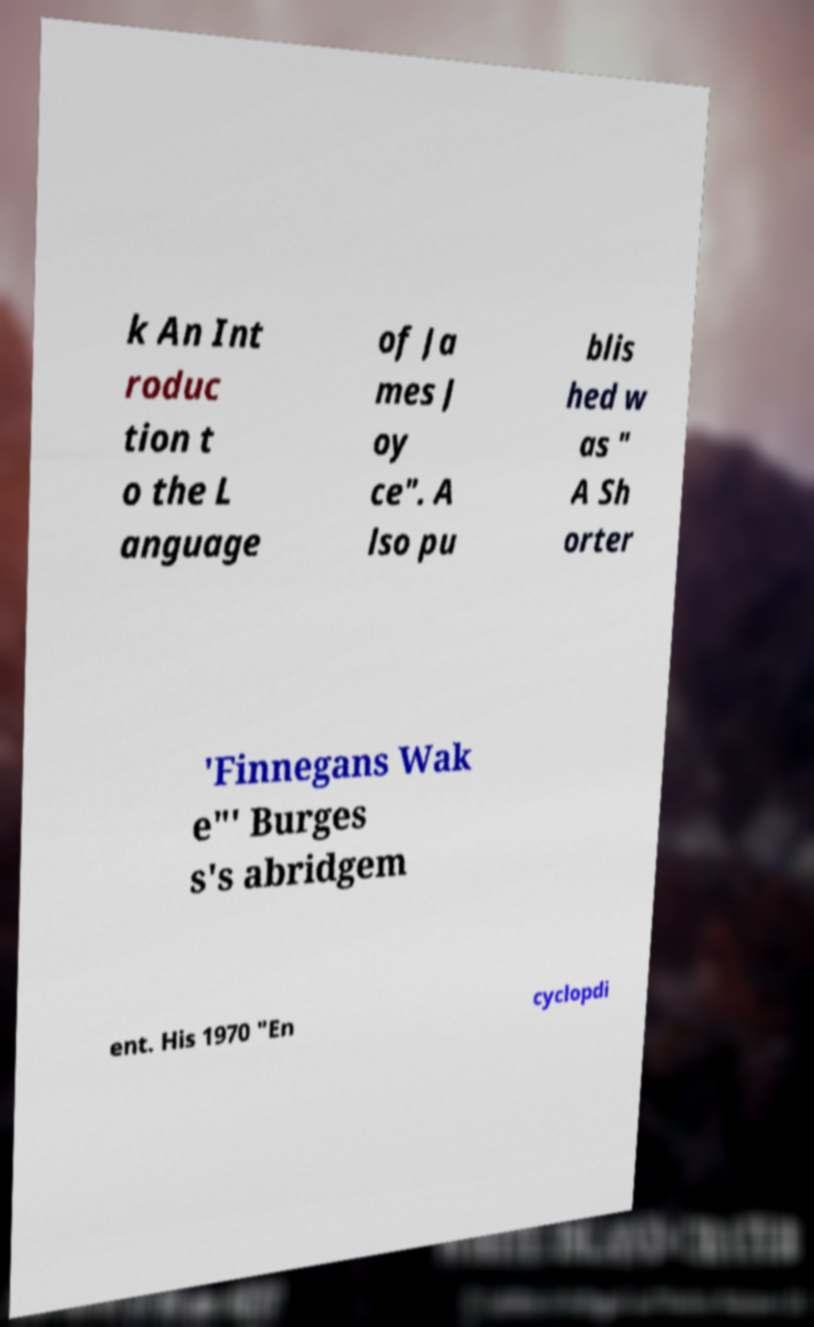There's text embedded in this image that I need extracted. Can you transcribe it verbatim? k An Int roduc tion t o the L anguage of Ja mes J oy ce". A lso pu blis hed w as " A Sh orter 'Finnegans Wak e"' Burges s's abridgem ent. His 1970 "En cyclopdi 